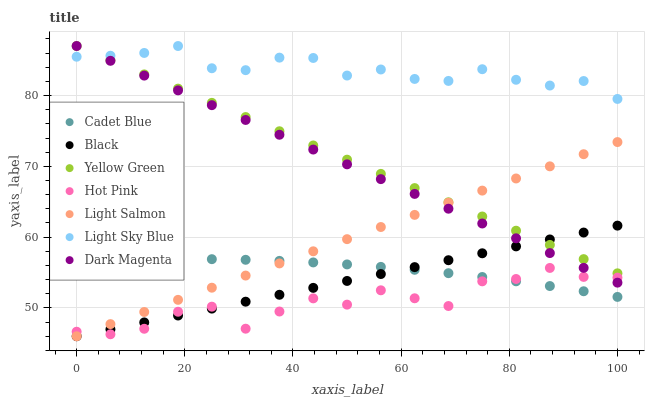Does Hot Pink have the minimum area under the curve?
Answer yes or no. Yes. Does Light Sky Blue have the maximum area under the curve?
Answer yes or no. Yes. Does Cadet Blue have the minimum area under the curve?
Answer yes or no. No. Does Cadet Blue have the maximum area under the curve?
Answer yes or no. No. Is Yellow Green the smoothest?
Answer yes or no. Yes. Is Hot Pink the roughest?
Answer yes or no. Yes. Is Cadet Blue the smoothest?
Answer yes or no. No. Is Cadet Blue the roughest?
Answer yes or no. No. Does Light Salmon have the lowest value?
Answer yes or no. Yes. Does Cadet Blue have the lowest value?
Answer yes or no. No. Does Dark Magenta have the highest value?
Answer yes or no. Yes. Does Cadet Blue have the highest value?
Answer yes or no. No. Is Black less than Light Sky Blue?
Answer yes or no. Yes. Is Light Sky Blue greater than Black?
Answer yes or no. Yes. Does Light Salmon intersect Black?
Answer yes or no. Yes. Is Light Salmon less than Black?
Answer yes or no. No. Is Light Salmon greater than Black?
Answer yes or no. No. Does Black intersect Light Sky Blue?
Answer yes or no. No. 